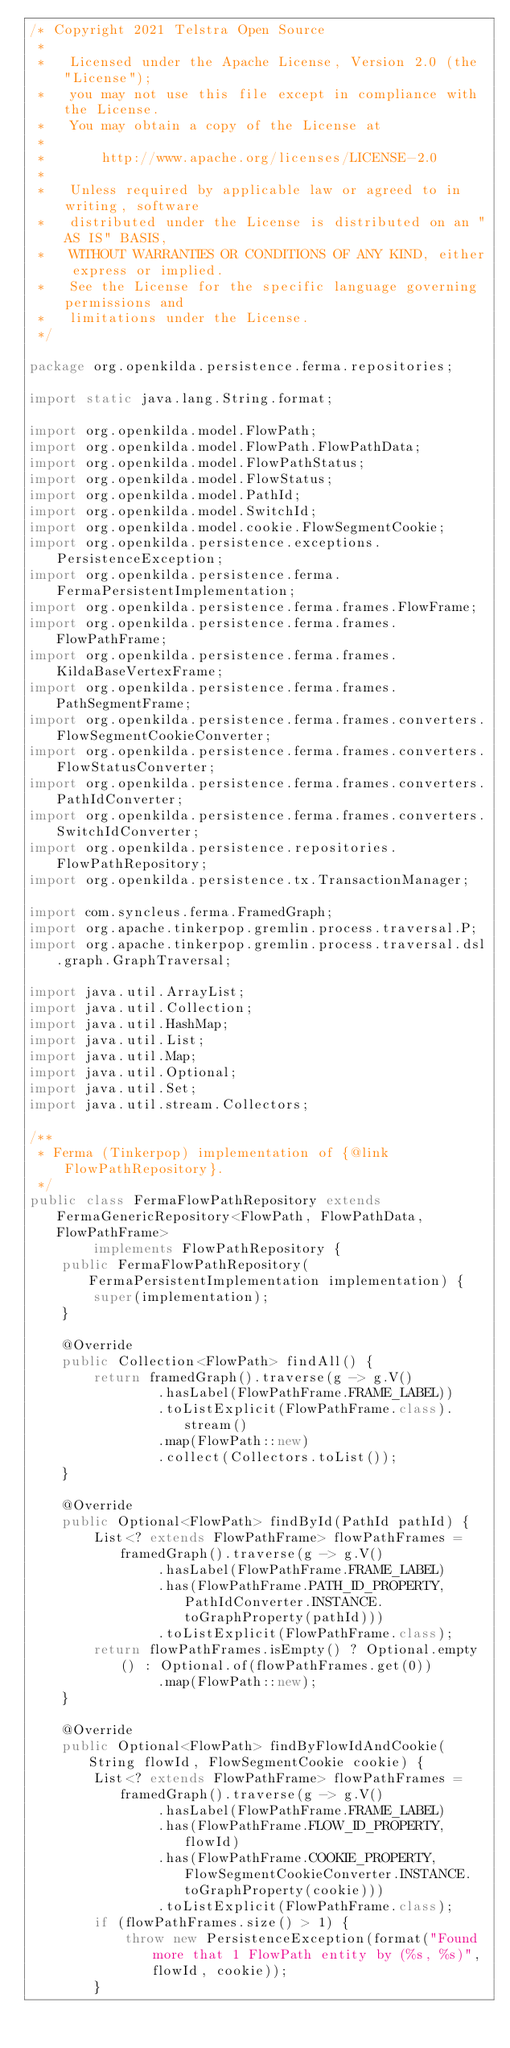Convert code to text. <code><loc_0><loc_0><loc_500><loc_500><_Java_>/* Copyright 2021 Telstra Open Source
 *
 *   Licensed under the Apache License, Version 2.0 (the "License");
 *   you may not use this file except in compliance with the License.
 *   You may obtain a copy of the License at
 *
 *       http://www.apache.org/licenses/LICENSE-2.0
 *
 *   Unless required by applicable law or agreed to in writing, software
 *   distributed under the License is distributed on an "AS IS" BASIS,
 *   WITHOUT WARRANTIES OR CONDITIONS OF ANY KIND, either express or implied.
 *   See the License for the specific language governing permissions and
 *   limitations under the License.
 */

package org.openkilda.persistence.ferma.repositories;

import static java.lang.String.format;

import org.openkilda.model.FlowPath;
import org.openkilda.model.FlowPath.FlowPathData;
import org.openkilda.model.FlowPathStatus;
import org.openkilda.model.FlowStatus;
import org.openkilda.model.PathId;
import org.openkilda.model.SwitchId;
import org.openkilda.model.cookie.FlowSegmentCookie;
import org.openkilda.persistence.exceptions.PersistenceException;
import org.openkilda.persistence.ferma.FermaPersistentImplementation;
import org.openkilda.persistence.ferma.frames.FlowFrame;
import org.openkilda.persistence.ferma.frames.FlowPathFrame;
import org.openkilda.persistence.ferma.frames.KildaBaseVertexFrame;
import org.openkilda.persistence.ferma.frames.PathSegmentFrame;
import org.openkilda.persistence.ferma.frames.converters.FlowSegmentCookieConverter;
import org.openkilda.persistence.ferma.frames.converters.FlowStatusConverter;
import org.openkilda.persistence.ferma.frames.converters.PathIdConverter;
import org.openkilda.persistence.ferma.frames.converters.SwitchIdConverter;
import org.openkilda.persistence.repositories.FlowPathRepository;
import org.openkilda.persistence.tx.TransactionManager;

import com.syncleus.ferma.FramedGraph;
import org.apache.tinkerpop.gremlin.process.traversal.P;
import org.apache.tinkerpop.gremlin.process.traversal.dsl.graph.GraphTraversal;

import java.util.ArrayList;
import java.util.Collection;
import java.util.HashMap;
import java.util.List;
import java.util.Map;
import java.util.Optional;
import java.util.Set;
import java.util.stream.Collectors;

/**
 * Ferma (Tinkerpop) implementation of {@link FlowPathRepository}.
 */
public class FermaFlowPathRepository extends FermaGenericRepository<FlowPath, FlowPathData, FlowPathFrame>
        implements FlowPathRepository {
    public FermaFlowPathRepository(FermaPersistentImplementation implementation) {
        super(implementation);
    }

    @Override
    public Collection<FlowPath> findAll() {
        return framedGraph().traverse(g -> g.V()
                .hasLabel(FlowPathFrame.FRAME_LABEL))
                .toListExplicit(FlowPathFrame.class).stream()
                .map(FlowPath::new)
                .collect(Collectors.toList());
    }

    @Override
    public Optional<FlowPath> findById(PathId pathId) {
        List<? extends FlowPathFrame> flowPathFrames = framedGraph().traverse(g -> g.V()
                .hasLabel(FlowPathFrame.FRAME_LABEL)
                .has(FlowPathFrame.PATH_ID_PROPERTY, PathIdConverter.INSTANCE.toGraphProperty(pathId)))
                .toListExplicit(FlowPathFrame.class);
        return flowPathFrames.isEmpty() ? Optional.empty() : Optional.of(flowPathFrames.get(0))
                .map(FlowPath::new);
    }

    @Override
    public Optional<FlowPath> findByFlowIdAndCookie(String flowId, FlowSegmentCookie cookie) {
        List<? extends FlowPathFrame> flowPathFrames = framedGraph().traverse(g -> g.V()
                .hasLabel(FlowPathFrame.FRAME_LABEL)
                .has(FlowPathFrame.FLOW_ID_PROPERTY, flowId)
                .has(FlowPathFrame.COOKIE_PROPERTY, FlowSegmentCookieConverter.INSTANCE.toGraphProperty(cookie)))
                .toListExplicit(FlowPathFrame.class);
        if (flowPathFrames.size() > 1) {
            throw new PersistenceException(format("Found more that 1 FlowPath entity by (%s, %s)", flowId, cookie));
        }</code> 